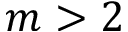<formula> <loc_0><loc_0><loc_500><loc_500>m > 2</formula> 